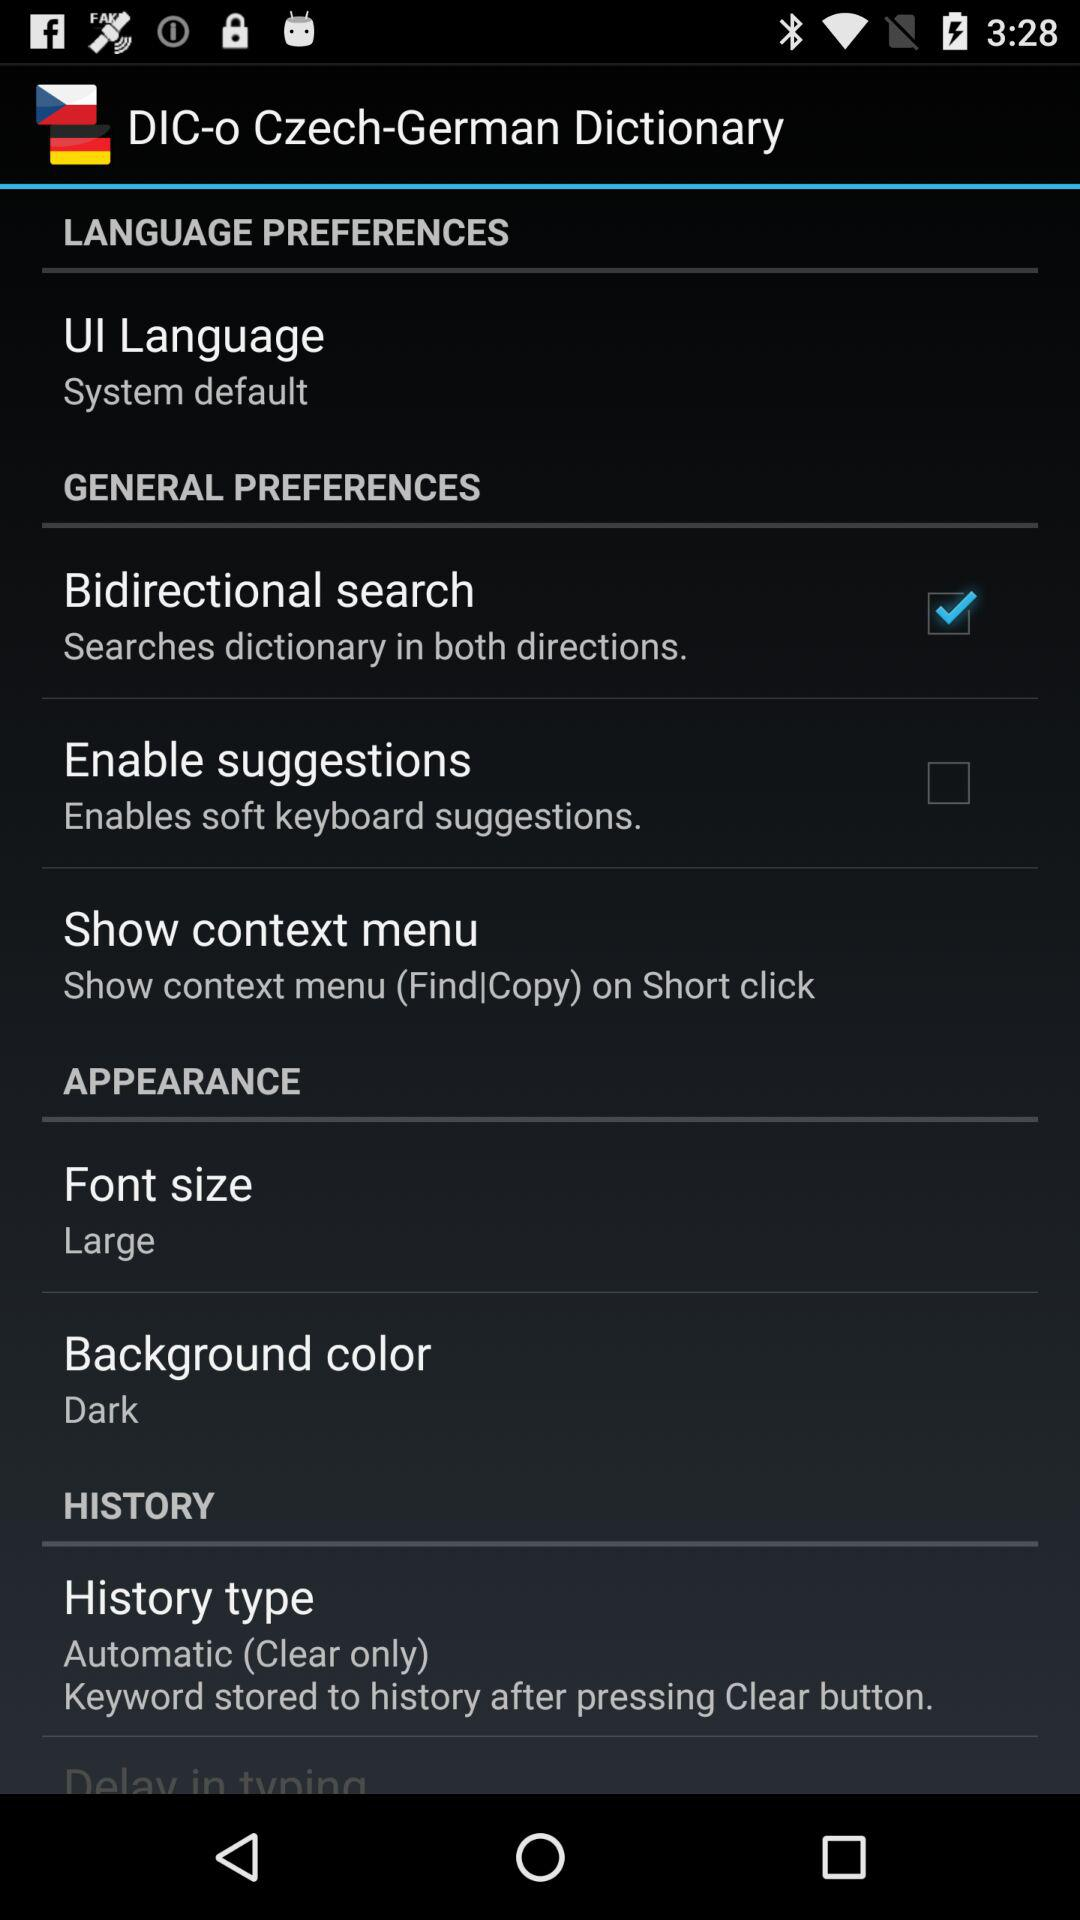What is the status of "Enable suggestions"? The status is "off". 